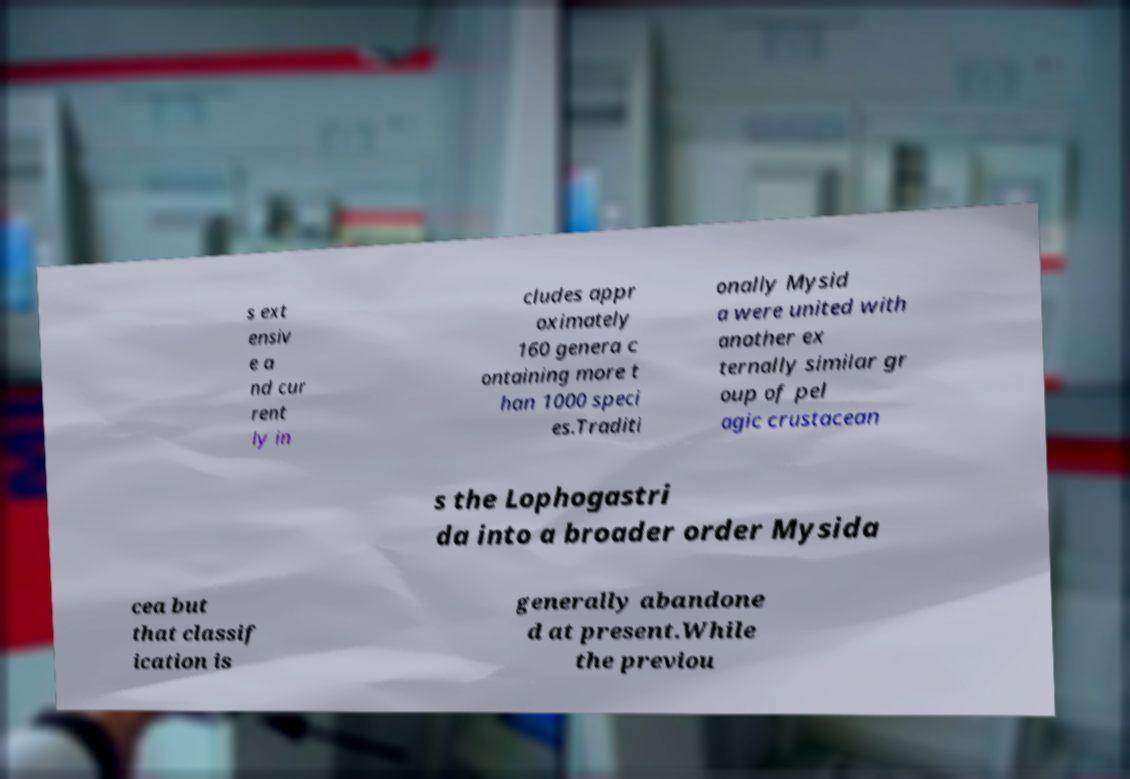I need the written content from this picture converted into text. Can you do that? s ext ensiv e a nd cur rent ly in cludes appr oximately 160 genera c ontaining more t han 1000 speci es.Traditi onally Mysid a were united with another ex ternally similar gr oup of pel agic crustacean s the Lophogastri da into a broader order Mysida cea but that classif ication is generally abandone d at present.While the previou 